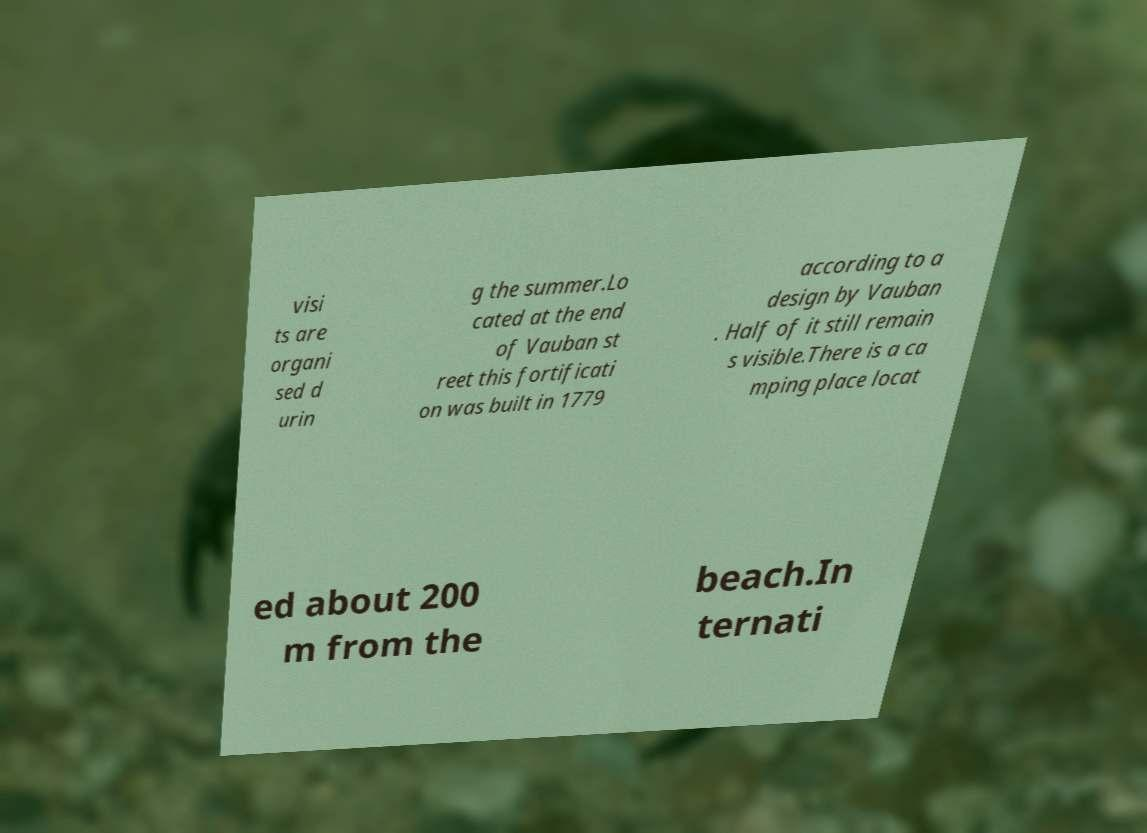Please read and relay the text visible in this image. What does it say? visi ts are organi sed d urin g the summer.Lo cated at the end of Vauban st reet this fortificati on was built in 1779 according to a design by Vauban . Half of it still remain s visible.There is a ca mping place locat ed about 200 m from the beach.In ternati 